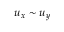<formula> <loc_0><loc_0><loc_500><loc_500>u _ { x } \sim u _ { y }</formula> 